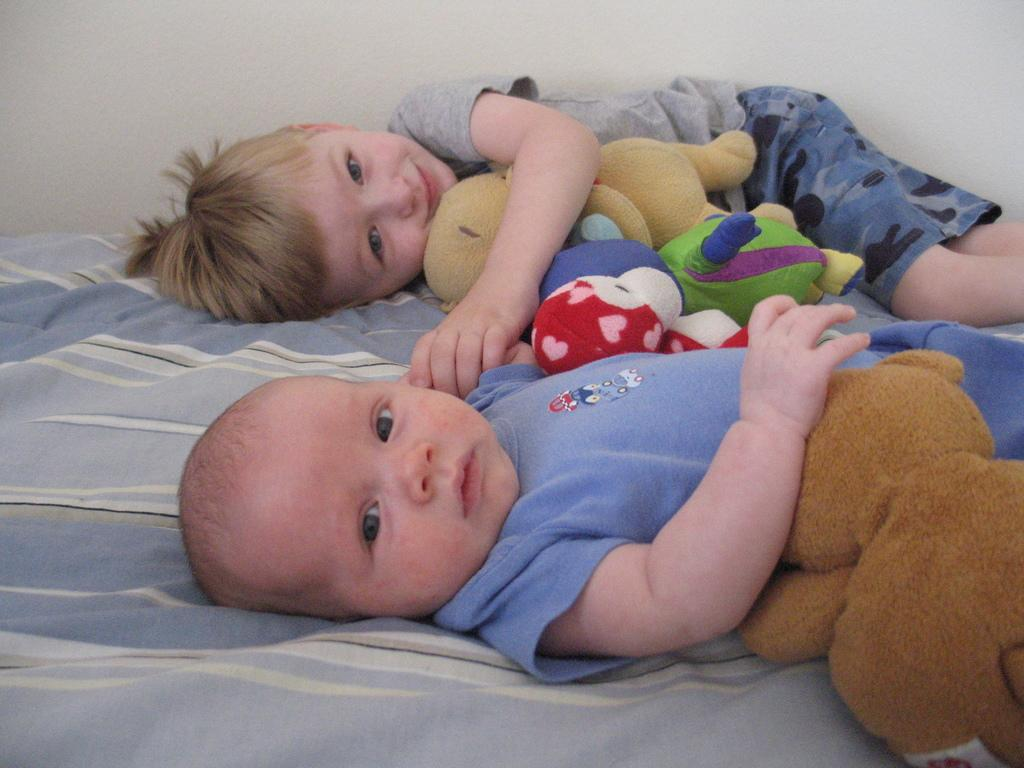How many children are present in the image? There are two children in the image. What are the children holding in the image? Both children are holding soft toys. Can you describe any other objects or materials in the image? There is a cloth visible in the image. How far away is the kite from the children in the image? There is no kite present in the image. 